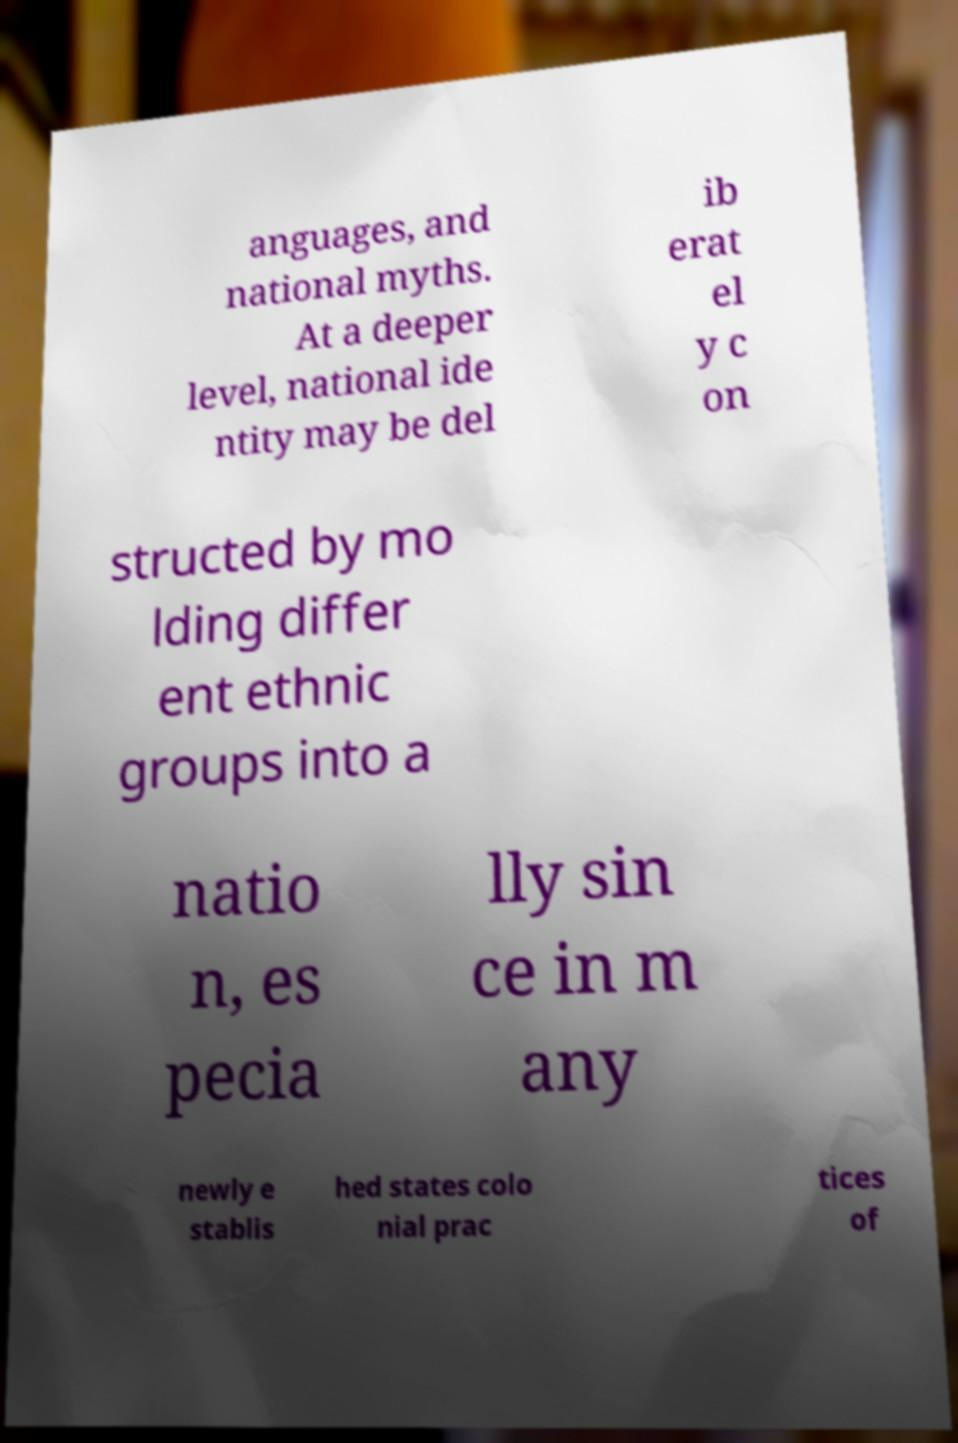Could you assist in decoding the text presented in this image and type it out clearly? anguages, and national myths. At a deeper level, national ide ntity may be del ib erat el y c on structed by mo lding differ ent ethnic groups into a natio n, es pecia lly sin ce in m any newly e stablis hed states colo nial prac tices of 